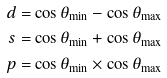<formula> <loc_0><loc_0><loc_500><loc_500>d & = \cos \theta _ { \min } - \cos \theta _ { \max } \\ s & = \cos \theta _ { \min } + \cos \theta _ { \max } \\ p & = \cos \theta _ { \min } \times \cos \theta _ { \max }</formula> 